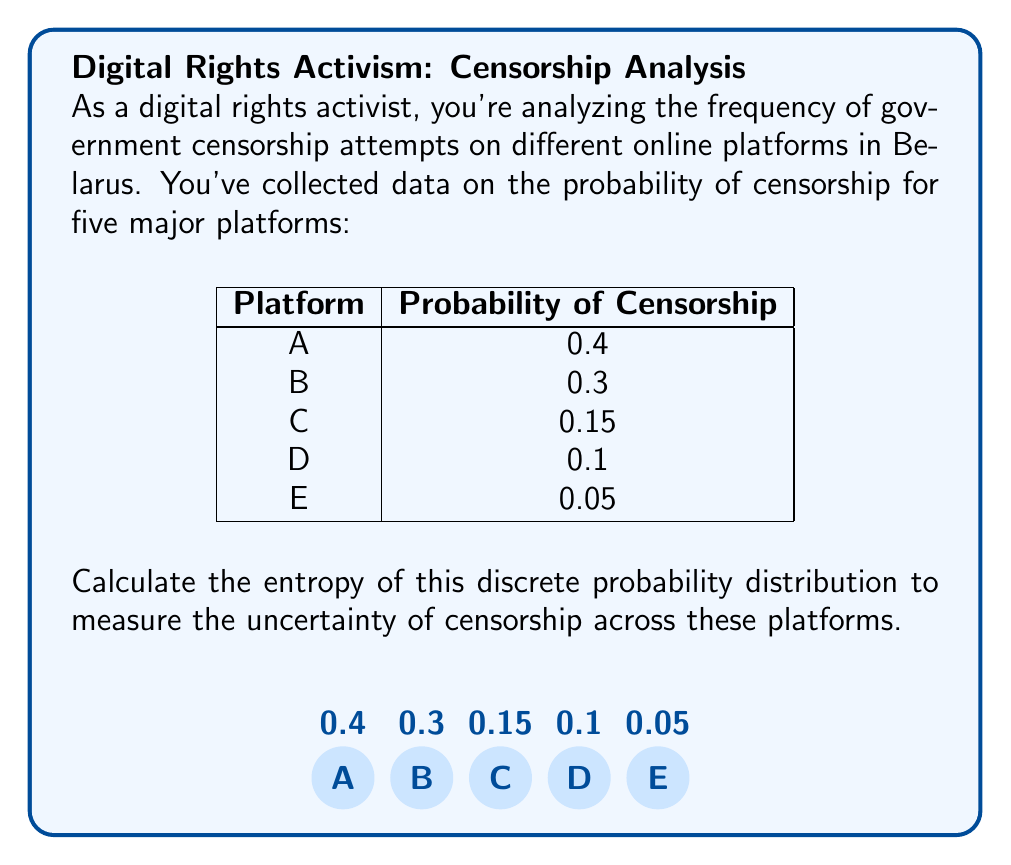Solve this math problem. To calculate the entropy of a discrete probability distribution, we use the formula:

$$ H = -\sum_{i=1}^n p_i \log_2(p_i) $$

where $p_i$ is the probability of each event and $n$ is the number of possible events.

Let's calculate each term:

1. For Platform A: $-0.4 \log_2(0.4) = 0.5288$
2. For Platform B: $-0.3 \log_2(0.3) = 0.5211$
3. For Platform C: $-0.15 \log_2(0.15) = 0.4105$
4. For Platform D: $-0.1 \log_2(0.1) = 0.3322$
5. For Platform E: $-0.05 \log_2(0.05) = 0.2161$

Now, sum all these terms:

$$ H = 0.5288 + 0.5211 + 0.4105 + 0.3322 + 0.2161 = 2.0087 $$

The entropy is approximately 2.0087 bits.
Answer: 2.0087 bits 